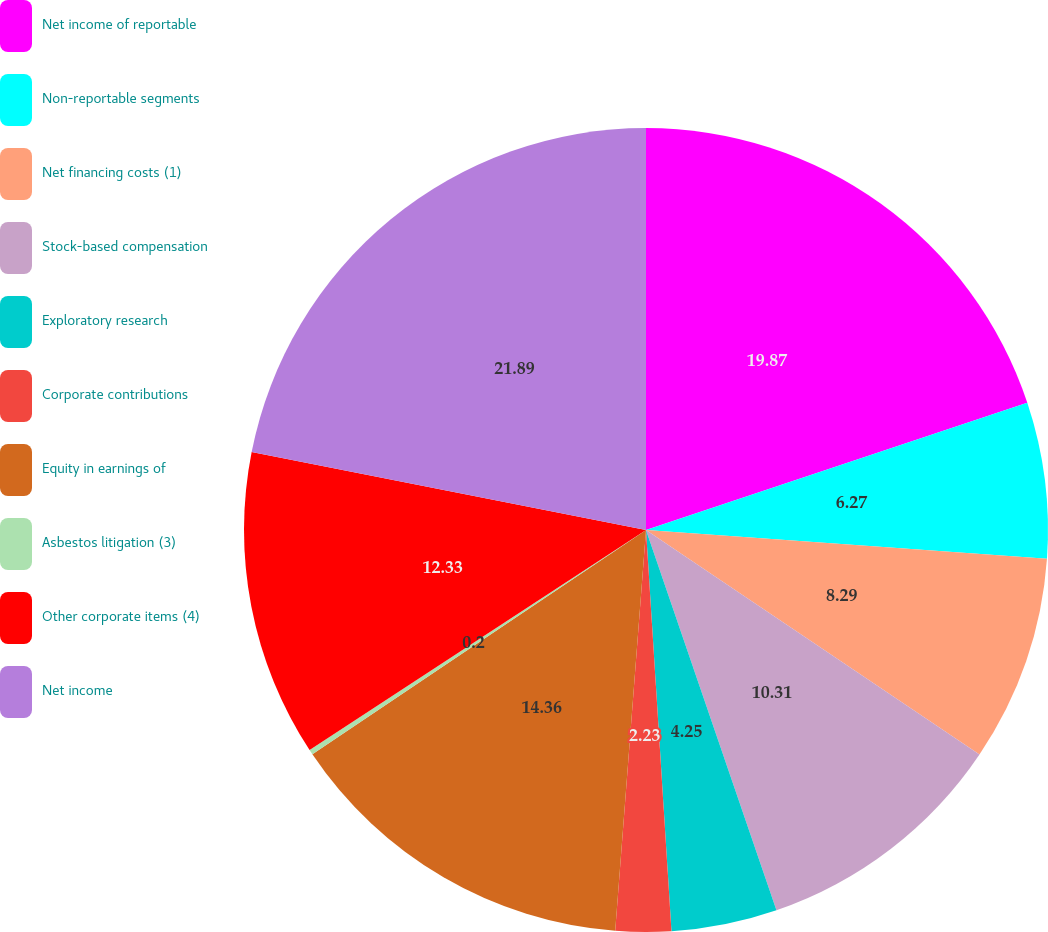Convert chart to OTSL. <chart><loc_0><loc_0><loc_500><loc_500><pie_chart><fcel>Net income of reportable<fcel>Non-reportable segments<fcel>Net financing costs (1)<fcel>Stock-based compensation<fcel>Exploratory research<fcel>Corporate contributions<fcel>Equity in earnings of<fcel>Asbestos litigation (3)<fcel>Other corporate items (4)<fcel>Net income<nl><fcel>19.87%<fcel>6.27%<fcel>8.29%<fcel>10.31%<fcel>4.25%<fcel>2.23%<fcel>14.36%<fcel>0.2%<fcel>12.33%<fcel>21.89%<nl></chart> 